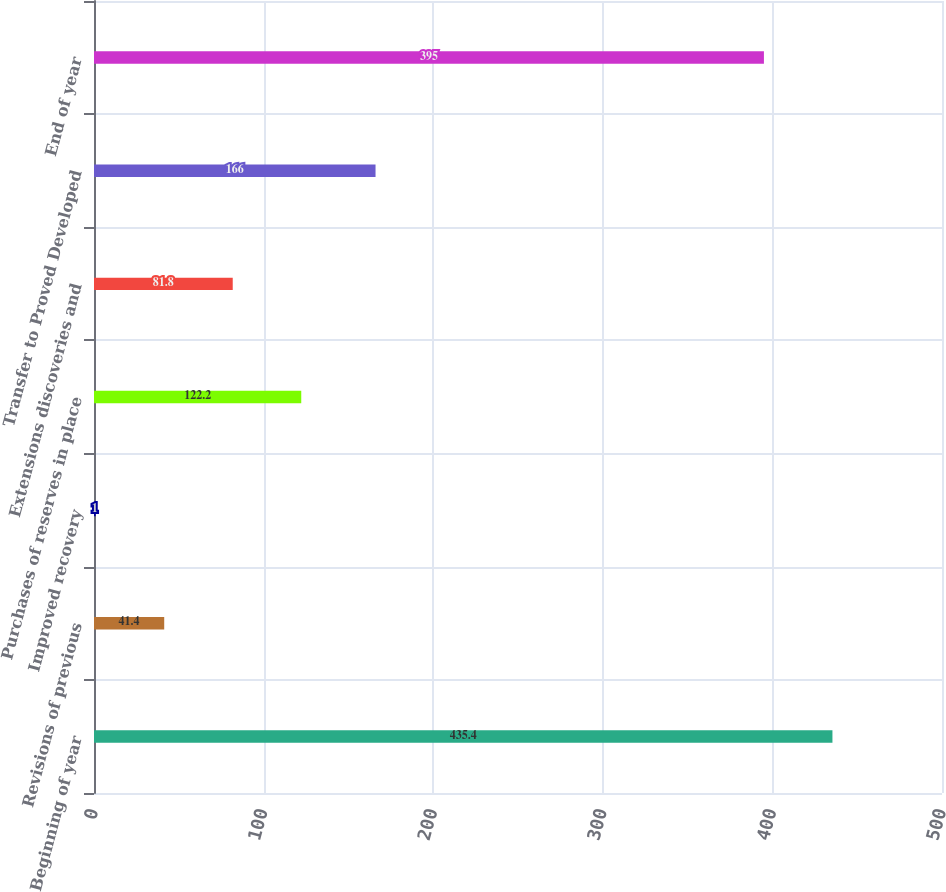Convert chart to OTSL. <chart><loc_0><loc_0><loc_500><loc_500><bar_chart><fcel>Beginning of year<fcel>Revisions of previous<fcel>Improved recovery<fcel>Purchases of reserves in place<fcel>Extensions discoveries and<fcel>Transfer to Proved Developed<fcel>End of year<nl><fcel>435.4<fcel>41.4<fcel>1<fcel>122.2<fcel>81.8<fcel>166<fcel>395<nl></chart> 